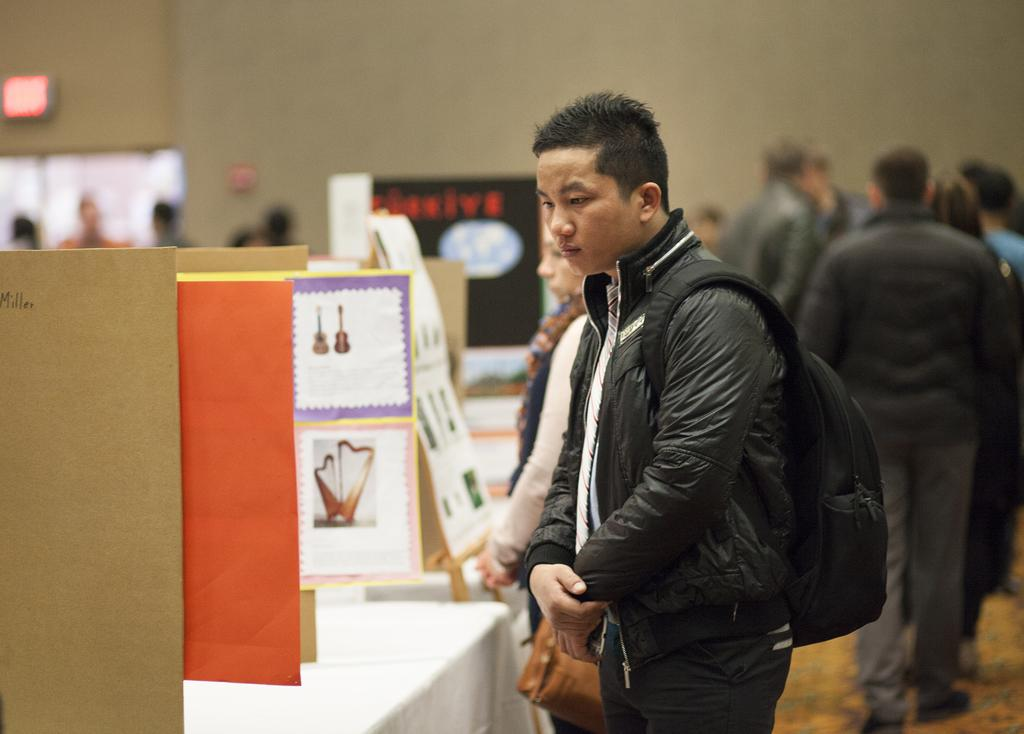What are the persons standing near in the image? The persons are standing at the hoardings. Where are the hoardings placed in the image? The hoardings are on tables. Can you describe the background of the image? The background of the image is blurred, and there are persons, a wall, hoardings, and other objects visible. How many pizzas are being served at the park in the image? There is no park or pizzas present in the image. What type of cap is the person in the background wearing? There is no person wearing a cap in the image. 